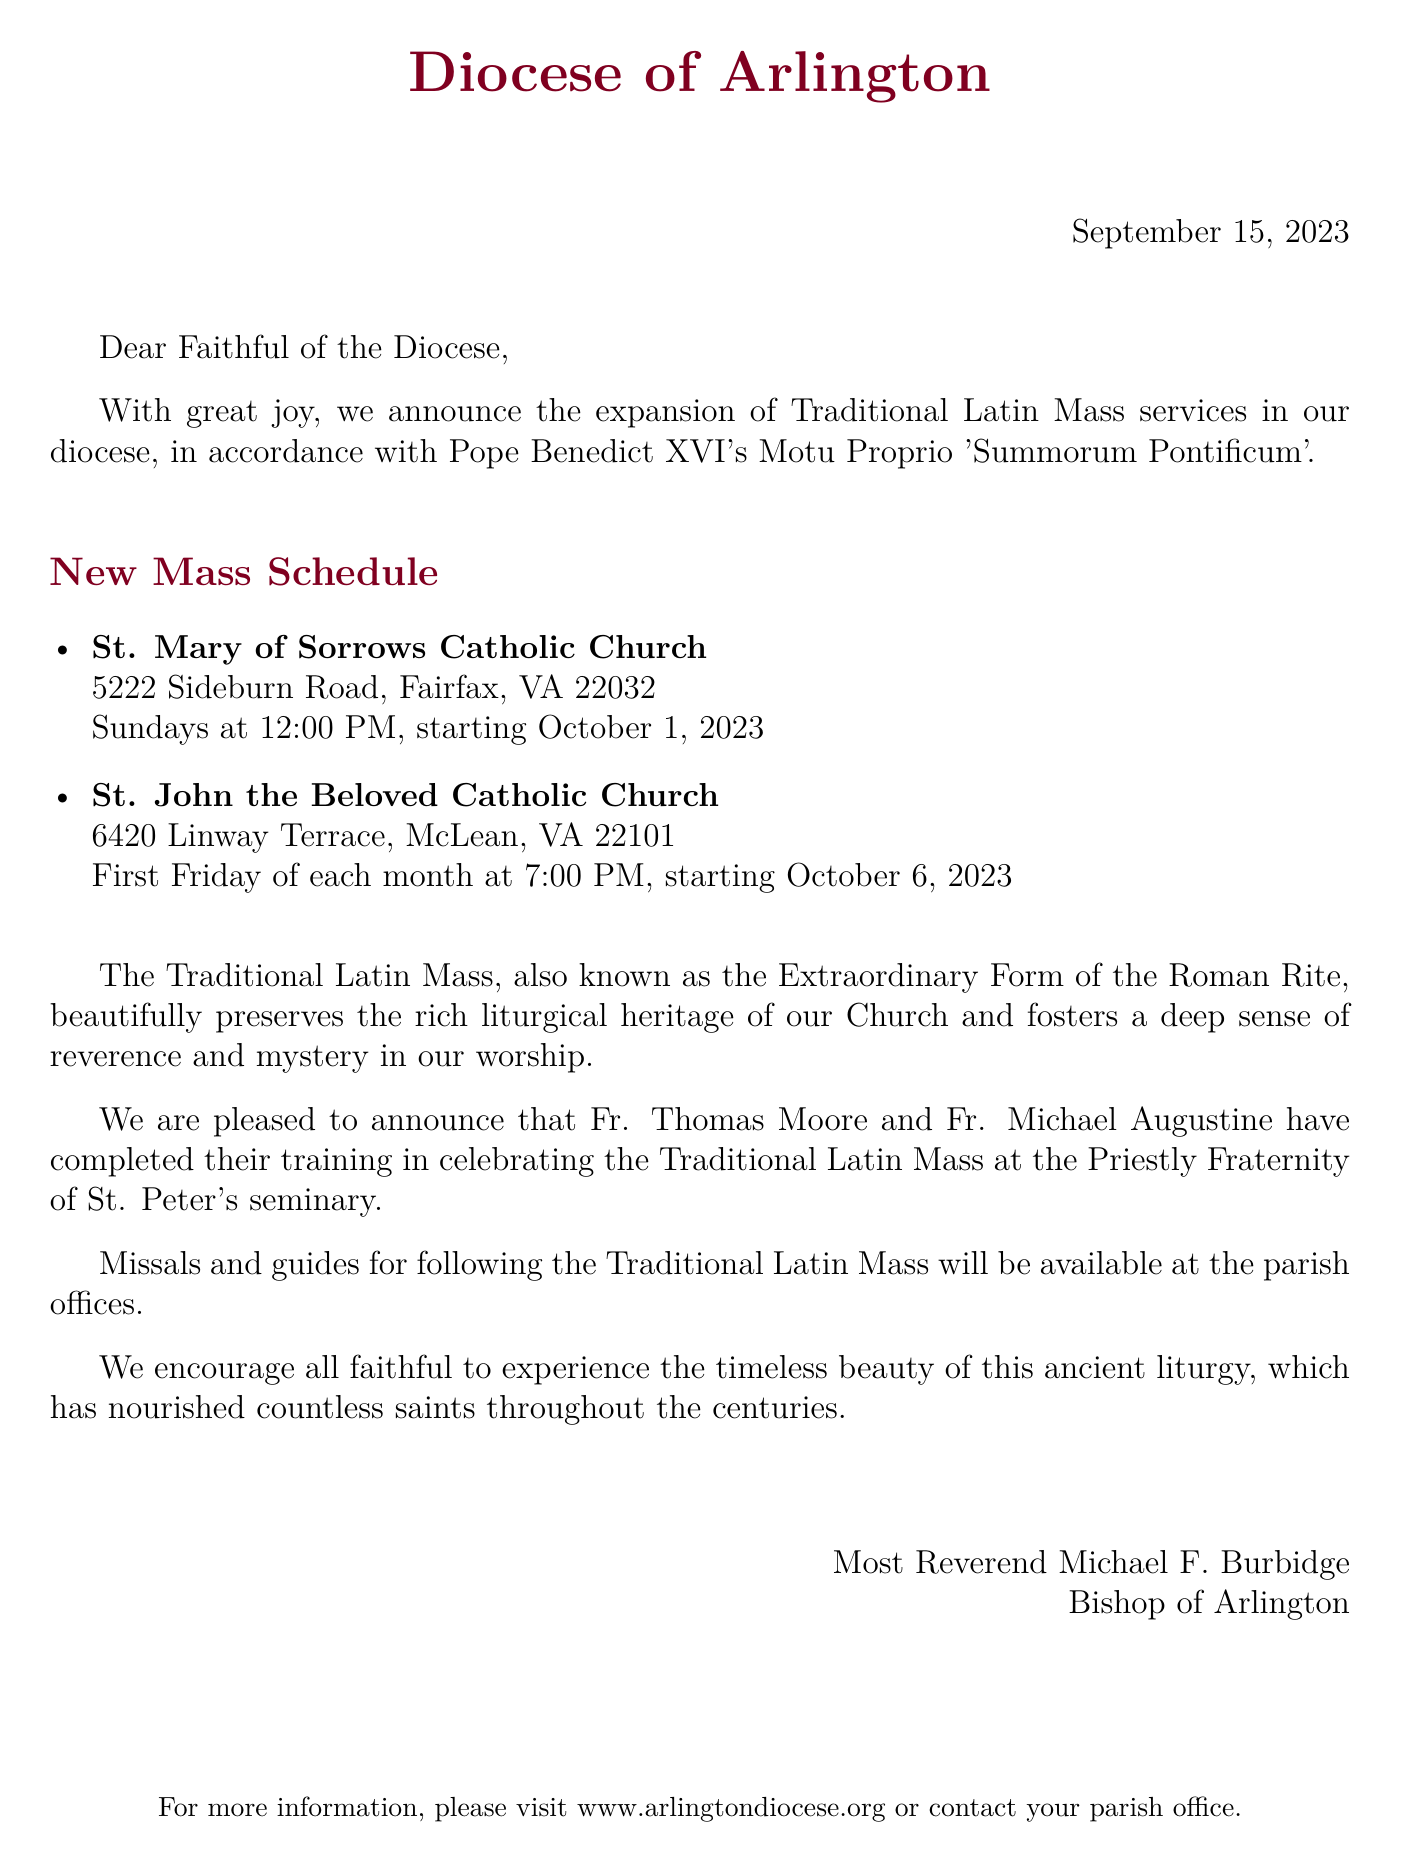What is the organization sending the letter? The organization is identified at the top of the document as the "Diocese of Arlington."
Answer: Diocese of Arlington What is the date of the announcement? The date is stated in the document as September 15, 2023.
Answer: September 15, 2023 What are the names of the two churches announced for Traditional Latin Mass? The document lists two churches, which are St. Mary of Sorrows Catholic Church and St. John the Beloved Catholic Church.
Answer: St. Mary of Sorrows Catholic Church, St. John the Beloved Catholic Church When does the Traditional Latin Mass begin at St. Mary of Sorrows Catholic Church? The beginning date for the Mass at this church is noted as October 1, 2023.
Answer: October 1, 2023 Who are the priests trained to celebrate the Traditional Latin Mass? The priests mentioned in the letter are Fr. Thomas Moore and Fr. Michael Augustine.
Answer: Fr. Thomas Moore, Fr. Michael Augustine What does the document encourage the faithful to do? The document encourages the faithful to experience the beauty of the Traditional Latin Mass.
Answer: Experience the timeless beauty On what day is the Traditional Latin Mass at St. John the Beloved Catholic Church held? The specific day mentioned for St. John the Beloved Catholic Church is the first Friday of each month.
Answer: First Friday of each month What is the available resource for those attending the Traditional Latin Mass? The document mentions that missals and guides will be available at the parish offices.
Answer: Missals and guides at parish offices 